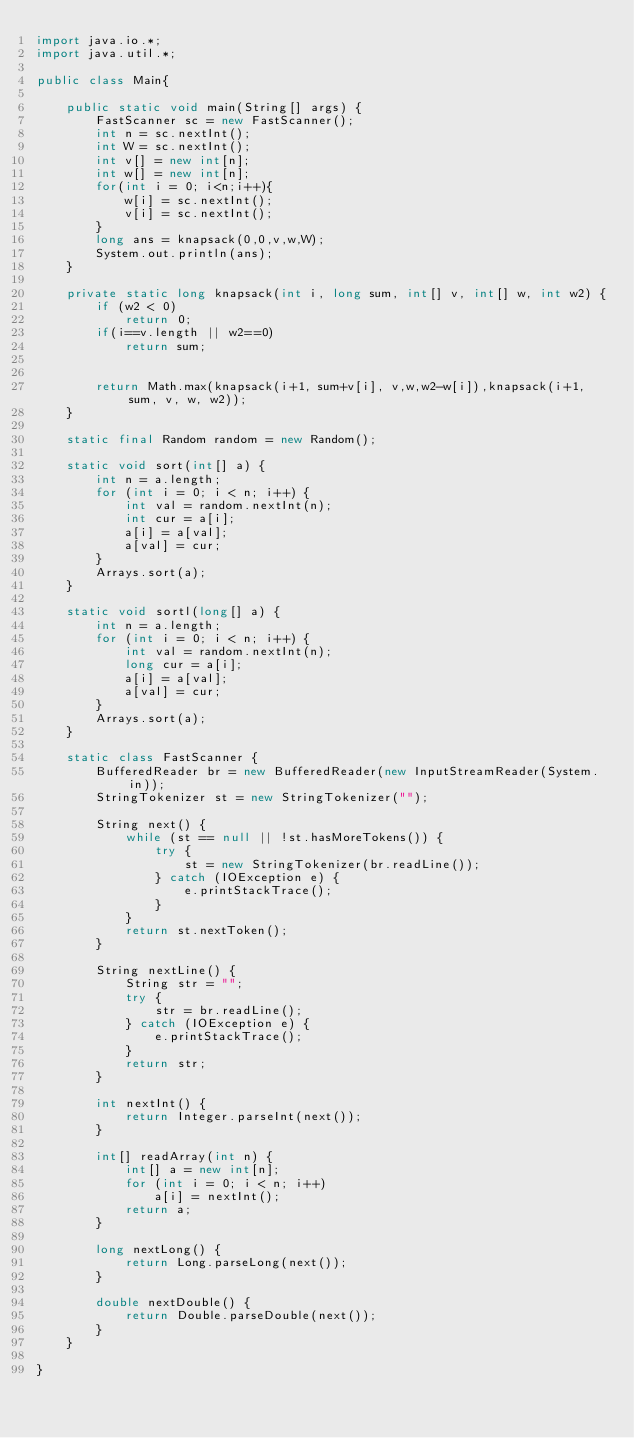<code> <loc_0><loc_0><loc_500><loc_500><_Java_>import java.io.*;
import java.util.*;

public class Main{

    public static void main(String[] args) {
        FastScanner sc = new FastScanner();
        int n = sc.nextInt();
        int W = sc.nextInt();
        int v[] = new int[n];
        int w[] = new int[n];
        for(int i = 0; i<n;i++){
            w[i] = sc.nextInt();
            v[i] = sc.nextInt();
        }
        long ans = knapsack(0,0,v,w,W);
        System.out.println(ans);
    }

    private static long knapsack(int i, long sum, int[] v, int[] w, int w2) {
        if (w2 < 0)
            return 0;
        if(i==v.length || w2==0)
            return sum;
       

        return Math.max(knapsack(i+1, sum+v[i], v,w,w2-w[i]),knapsack(i+1, sum, v, w, w2));
    }

    static final Random random = new Random();

    static void sort(int[] a) {
        int n = a.length;
        for (int i = 0; i < n; i++) {
            int val = random.nextInt(n);
            int cur = a[i];
            a[i] = a[val];
            a[val] = cur;
        }
        Arrays.sort(a);
    }

    static void sortl(long[] a) {
        int n = a.length;
        for (int i = 0; i < n; i++) {
            int val = random.nextInt(n);
            long cur = a[i];
            a[i] = a[val];
            a[val] = cur;
        }
        Arrays.sort(a);
    }

    static class FastScanner {
        BufferedReader br = new BufferedReader(new InputStreamReader(System.in));
        StringTokenizer st = new StringTokenizer("");

        String next() {
            while (st == null || !st.hasMoreTokens()) {
                try {
                    st = new StringTokenizer(br.readLine());
                } catch (IOException e) {
                    e.printStackTrace();
                }
            }
            return st.nextToken();
        }

        String nextLine() {
            String str = "";
            try {
                str = br.readLine();
            } catch (IOException e) {
                e.printStackTrace();
            }
            return str;
        }

        int nextInt() {
            return Integer.parseInt(next());
        }

        int[] readArray(int n) {
            int[] a = new int[n];
            for (int i = 0; i < n; i++)
                a[i] = nextInt();
            return a;
        }

        long nextLong() {
            return Long.parseLong(next());
        }

        double nextDouble() {
            return Double.parseDouble(next());
        }
    }

}
</code> 